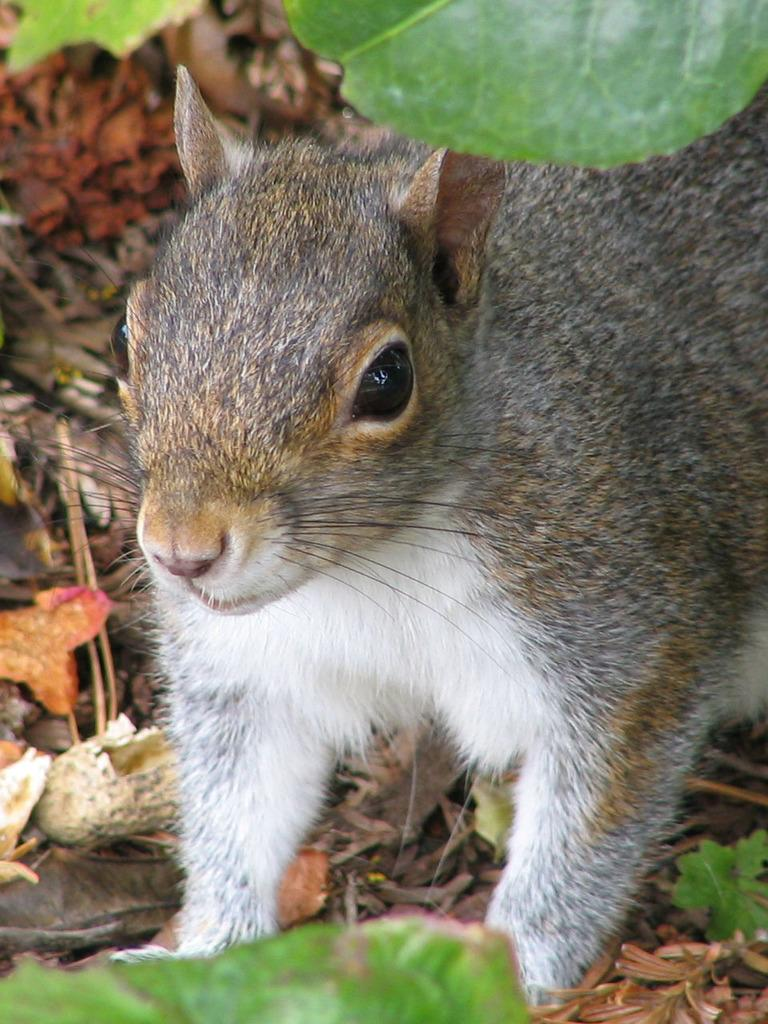What type of animal can be seen in the image? There is a squirrel in the image. What is present at the bottom of the image? Dry leaves are present at the bottom of the image. What color is the leaf at the top of the image? There is a green leaf at the top of the image. Can you see the squirrel's toes in the image? There is no indication of the squirrel's toes in the image, as it is not focused on that level of detail. 